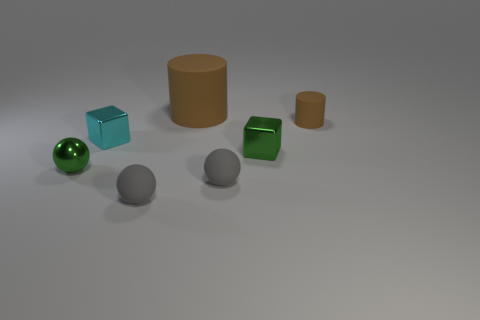Do the cylinder that is in front of the large brown object and the cylinder on the left side of the green cube have the same color?
Provide a succinct answer. Yes. Is the number of tiny cyan metal objects that are behind the big rubber cylinder greater than the number of brown cylinders?
Your answer should be compact. No. What is the material of the green sphere?
Make the answer very short. Metal. There is a cyan object that is made of the same material as the tiny green cube; what is its shape?
Your answer should be very brief. Cube. How big is the rubber cylinder that is behind the brown object that is on the right side of the tiny green metal block?
Give a very brief answer. Large. The cylinder on the left side of the small brown thing is what color?
Give a very brief answer. Brown. Are there any small brown matte things of the same shape as the big rubber thing?
Your answer should be compact. Yes. Are there fewer small brown objects that are in front of the cyan metallic block than green shiny objects that are right of the big matte cylinder?
Make the answer very short. Yes. What is the color of the shiny ball?
Keep it short and to the point. Green. Is there a small gray object behind the rubber ball that is to the left of the large brown rubber thing?
Offer a terse response. Yes. 